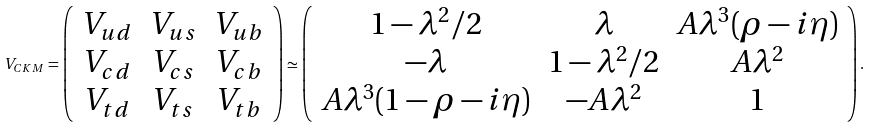<formula> <loc_0><loc_0><loc_500><loc_500>V _ { C K M } = \left ( \begin{array} { c c c } V _ { u d } & V _ { u s } & V _ { u b } \\ V _ { c d } & V _ { c s } & V _ { c b } \\ V _ { t d } & V _ { t s } & V _ { t b } \end{array} \right ) \simeq \left ( \begin{array} { c c c } 1 - \lambda ^ { 2 } / 2 & \lambda & A \lambda ^ { 3 } ( \rho - i \eta ) \\ - \lambda & 1 - \lambda ^ { 2 } / 2 & A \lambda ^ { 2 } \\ A \lambda ^ { 3 } ( 1 - \rho - i \eta ) & - A \lambda ^ { 2 } & 1 \end{array} \right ) .</formula> 